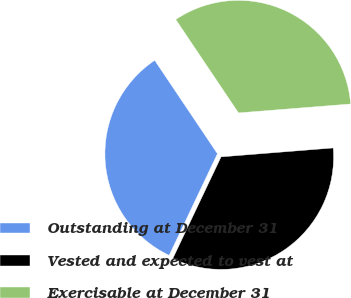Convert chart. <chart><loc_0><loc_0><loc_500><loc_500><pie_chart><fcel>Outstanding at December 31<fcel>Vested and expected to vest at<fcel>Exercisable at December 31<nl><fcel>33.53%<fcel>33.32%<fcel>33.15%<nl></chart> 